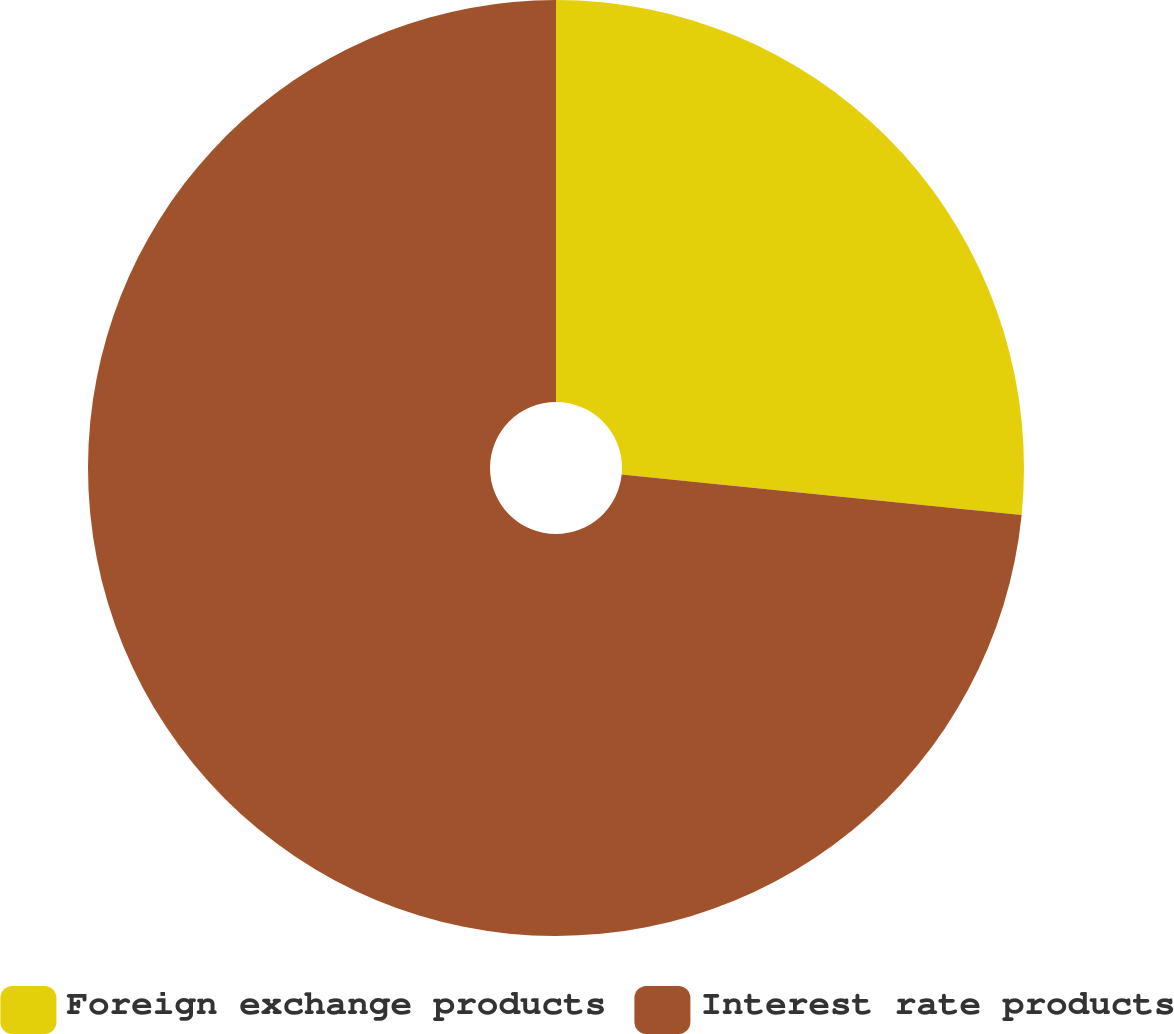Convert chart. <chart><loc_0><loc_0><loc_500><loc_500><pie_chart><fcel>Foreign exchange products<fcel>Interest rate products<nl><fcel>26.6%<fcel>73.4%<nl></chart> 